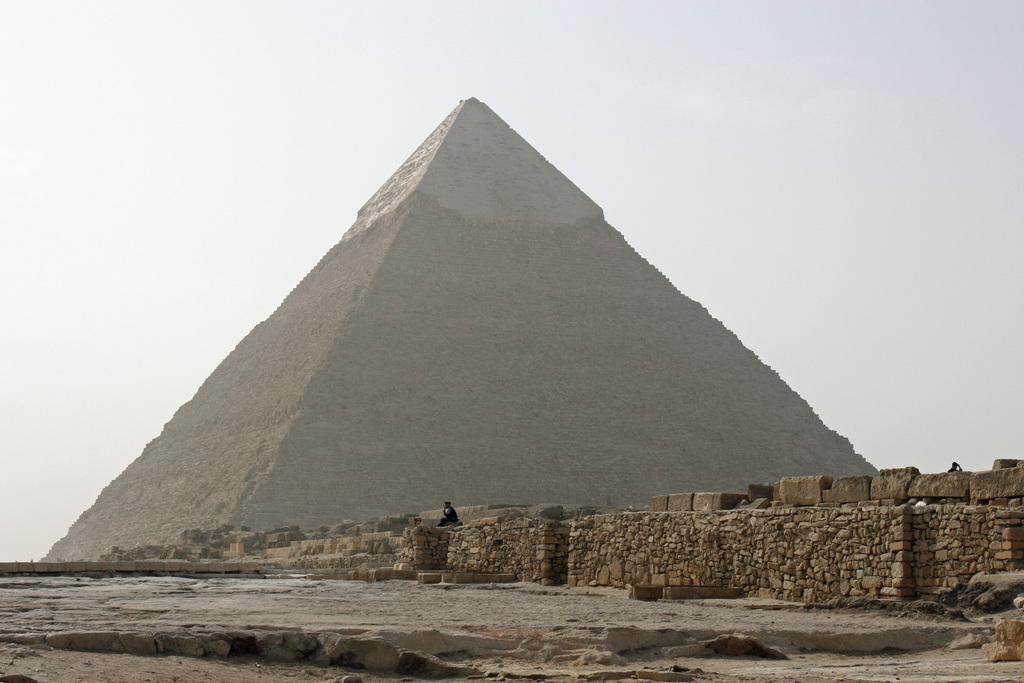Please provide a concise description of this image. In this image I can see a pyramid and stone wall. I can see two people. The sky is in white and blue color. 